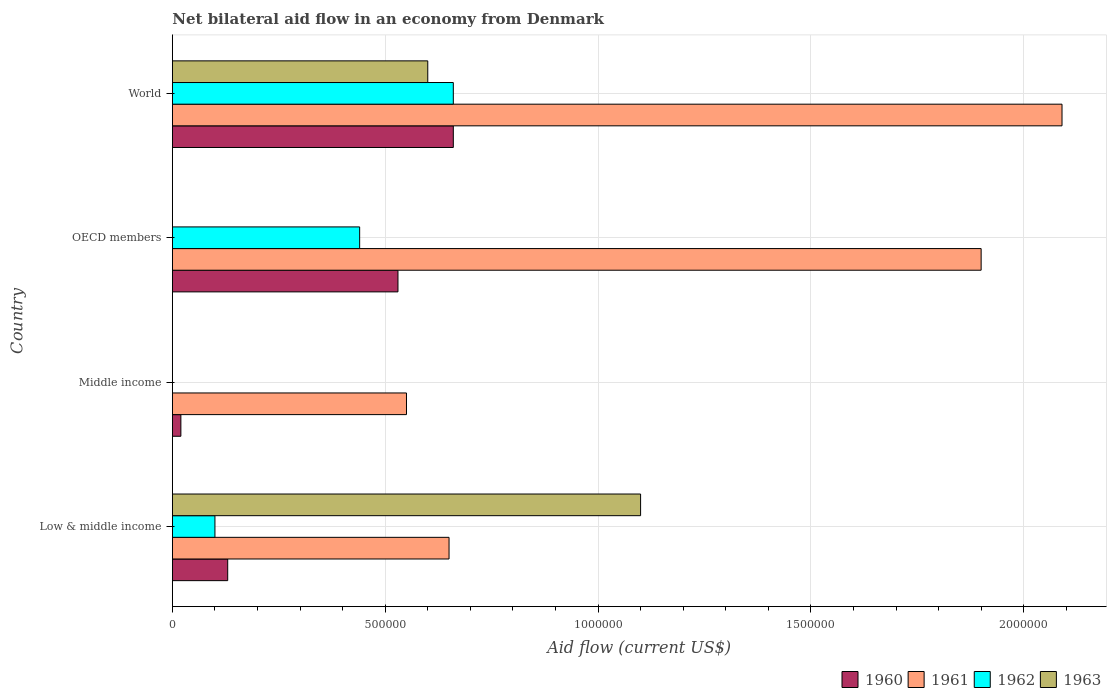How many different coloured bars are there?
Your response must be concise. 4. How many groups of bars are there?
Your answer should be very brief. 4. Are the number of bars per tick equal to the number of legend labels?
Your response must be concise. No. Are the number of bars on each tick of the Y-axis equal?
Your answer should be very brief. No. In how many cases, is the number of bars for a given country not equal to the number of legend labels?
Offer a terse response. 2. Across all countries, what is the maximum net bilateral aid flow in 1961?
Your answer should be compact. 2.09e+06. What is the total net bilateral aid flow in 1963 in the graph?
Ensure brevity in your answer.  1.70e+06. What is the difference between the net bilateral aid flow in 1960 in Middle income and that in OECD members?
Give a very brief answer. -5.10e+05. What is the difference between the net bilateral aid flow in 1963 in OECD members and the net bilateral aid flow in 1962 in World?
Your response must be concise. -6.60e+05. What is the difference between the net bilateral aid flow in 1960 and net bilateral aid flow in 1961 in OECD members?
Make the answer very short. -1.37e+06. In how many countries, is the net bilateral aid flow in 1963 greater than 1800000 US$?
Give a very brief answer. 0. What is the ratio of the net bilateral aid flow in 1961 in Low & middle income to that in World?
Give a very brief answer. 0.31. Is the net bilateral aid flow in 1961 in Middle income less than that in OECD members?
Give a very brief answer. Yes. Is the difference between the net bilateral aid flow in 1960 in Middle income and OECD members greater than the difference between the net bilateral aid flow in 1961 in Middle income and OECD members?
Provide a succinct answer. Yes. What is the difference between the highest and the second highest net bilateral aid flow in 1960?
Make the answer very short. 1.30e+05. What is the difference between the highest and the lowest net bilateral aid flow in 1963?
Your answer should be very brief. 1.10e+06. Are all the bars in the graph horizontal?
Your answer should be very brief. Yes. Are the values on the major ticks of X-axis written in scientific E-notation?
Make the answer very short. No. Does the graph contain grids?
Offer a terse response. Yes. How many legend labels are there?
Provide a succinct answer. 4. What is the title of the graph?
Provide a short and direct response. Net bilateral aid flow in an economy from Denmark. Does "2003" appear as one of the legend labels in the graph?
Offer a very short reply. No. What is the label or title of the X-axis?
Your answer should be very brief. Aid flow (current US$). What is the Aid flow (current US$) of 1961 in Low & middle income?
Your response must be concise. 6.50e+05. What is the Aid flow (current US$) in 1963 in Low & middle income?
Your response must be concise. 1.10e+06. What is the Aid flow (current US$) in 1960 in Middle income?
Ensure brevity in your answer.  2.00e+04. What is the Aid flow (current US$) in 1961 in Middle income?
Your response must be concise. 5.50e+05. What is the Aid flow (current US$) in 1960 in OECD members?
Offer a very short reply. 5.30e+05. What is the Aid flow (current US$) in 1961 in OECD members?
Make the answer very short. 1.90e+06. What is the Aid flow (current US$) in 1960 in World?
Your answer should be compact. 6.60e+05. What is the Aid flow (current US$) in 1961 in World?
Provide a short and direct response. 2.09e+06. What is the Aid flow (current US$) in 1962 in World?
Give a very brief answer. 6.60e+05. What is the Aid flow (current US$) of 1963 in World?
Your answer should be very brief. 6.00e+05. Across all countries, what is the maximum Aid flow (current US$) in 1961?
Give a very brief answer. 2.09e+06. Across all countries, what is the maximum Aid flow (current US$) of 1962?
Your answer should be compact. 6.60e+05. Across all countries, what is the maximum Aid flow (current US$) in 1963?
Your answer should be compact. 1.10e+06. Across all countries, what is the minimum Aid flow (current US$) in 1961?
Your answer should be compact. 5.50e+05. Across all countries, what is the minimum Aid flow (current US$) in 1962?
Ensure brevity in your answer.  0. What is the total Aid flow (current US$) of 1960 in the graph?
Offer a very short reply. 1.34e+06. What is the total Aid flow (current US$) in 1961 in the graph?
Offer a very short reply. 5.19e+06. What is the total Aid flow (current US$) of 1962 in the graph?
Keep it short and to the point. 1.20e+06. What is the total Aid flow (current US$) in 1963 in the graph?
Offer a very short reply. 1.70e+06. What is the difference between the Aid flow (current US$) of 1960 in Low & middle income and that in OECD members?
Keep it short and to the point. -4.00e+05. What is the difference between the Aid flow (current US$) in 1961 in Low & middle income and that in OECD members?
Keep it short and to the point. -1.25e+06. What is the difference between the Aid flow (current US$) of 1962 in Low & middle income and that in OECD members?
Offer a terse response. -3.40e+05. What is the difference between the Aid flow (current US$) in 1960 in Low & middle income and that in World?
Your answer should be very brief. -5.30e+05. What is the difference between the Aid flow (current US$) in 1961 in Low & middle income and that in World?
Offer a very short reply. -1.44e+06. What is the difference between the Aid flow (current US$) in 1962 in Low & middle income and that in World?
Your response must be concise. -5.60e+05. What is the difference between the Aid flow (current US$) in 1963 in Low & middle income and that in World?
Provide a succinct answer. 5.00e+05. What is the difference between the Aid flow (current US$) in 1960 in Middle income and that in OECD members?
Offer a very short reply. -5.10e+05. What is the difference between the Aid flow (current US$) of 1961 in Middle income and that in OECD members?
Offer a terse response. -1.35e+06. What is the difference between the Aid flow (current US$) of 1960 in Middle income and that in World?
Give a very brief answer. -6.40e+05. What is the difference between the Aid flow (current US$) in 1961 in Middle income and that in World?
Give a very brief answer. -1.54e+06. What is the difference between the Aid flow (current US$) in 1960 in OECD members and that in World?
Ensure brevity in your answer.  -1.30e+05. What is the difference between the Aid flow (current US$) in 1961 in OECD members and that in World?
Provide a short and direct response. -1.90e+05. What is the difference between the Aid flow (current US$) in 1960 in Low & middle income and the Aid flow (current US$) in 1961 in Middle income?
Offer a terse response. -4.20e+05. What is the difference between the Aid flow (current US$) of 1960 in Low & middle income and the Aid flow (current US$) of 1961 in OECD members?
Your answer should be compact. -1.77e+06. What is the difference between the Aid flow (current US$) in 1960 in Low & middle income and the Aid flow (current US$) in 1962 in OECD members?
Provide a succinct answer. -3.10e+05. What is the difference between the Aid flow (current US$) of 1961 in Low & middle income and the Aid flow (current US$) of 1962 in OECD members?
Keep it short and to the point. 2.10e+05. What is the difference between the Aid flow (current US$) in 1960 in Low & middle income and the Aid flow (current US$) in 1961 in World?
Give a very brief answer. -1.96e+06. What is the difference between the Aid flow (current US$) in 1960 in Low & middle income and the Aid flow (current US$) in 1962 in World?
Ensure brevity in your answer.  -5.30e+05. What is the difference between the Aid flow (current US$) in 1960 in Low & middle income and the Aid flow (current US$) in 1963 in World?
Keep it short and to the point. -4.70e+05. What is the difference between the Aid flow (current US$) of 1962 in Low & middle income and the Aid flow (current US$) of 1963 in World?
Give a very brief answer. -5.00e+05. What is the difference between the Aid flow (current US$) in 1960 in Middle income and the Aid flow (current US$) in 1961 in OECD members?
Give a very brief answer. -1.88e+06. What is the difference between the Aid flow (current US$) in 1960 in Middle income and the Aid flow (current US$) in 1962 in OECD members?
Give a very brief answer. -4.20e+05. What is the difference between the Aid flow (current US$) in 1960 in Middle income and the Aid flow (current US$) in 1961 in World?
Offer a very short reply. -2.07e+06. What is the difference between the Aid flow (current US$) in 1960 in Middle income and the Aid flow (current US$) in 1962 in World?
Your answer should be compact. -6.40e+05. What is the difference between the Aid flow (current US$) of 1960 in Middle income and the Aid flow (current US$) of 1963 in World?
Your response must be concise. -5.80e+05. What is the difference between the Aid flow (current US$) of 1961 in Middle income and the Aid flow (current US$) of 1962 in World?
Make the answer very short. -1.10e+05. What is the difference between the Aid flow (current US$) in 1961 in Middle income and the Aid flow (current US$) in 1963 in World?
Your answer should be very brief. -5.00e+04. What is the difference between the Aid flow (current US$) in 1960 in OECD members and the Aid flow (current US$) in 1961 in World?
Make the answer very short. -1.56e+06. What is the difference between the Aid flow (current US$) of 1960 in OECD members and the Aid flow (current US$) of 1962 in World?
Your response must be concise. -1.30e+05. What is the difference between the Aid flow (current US$) of 1960 in OECD members and the Aid flow (current US$) of 1963 in World?
Make the answer very short. -7.00e+04. What is the difference between the Aid flow (current US$) in 1961 in OECD members and the Aid flow (current US$) in 1962 in World?
Offer a terse response. 1.24e+06. What is the difference between the Aid flow (current US$) of 1961 in OECD members and the Aid flow (current US$) of 1963 in World?
Offer a very short reply. 1.30e+06. What is the difference between the Aid flow (current US$) in 1962 in OECD members and the Aid flow (current US$) in 1963 in World?
Your response must be concise. -1.60e+05. What is the average Aid flow (current US$) in 1960 per country?
Your answer should be compact. 3.35e+05. What is the average Aid flow (current US$) of 1961 per country?
Ensure brevity in your answer.  1.30e+06. What is the average Aid flow (current US$) in 1962 per country?
Give a very brief answer. 3.00e+05. What is the average Aid flow (current US$) of 1963 per country?
Provide a short and direct response. 4.25e+05. What is the difference between the Aid flow (current US$) in 1960 and Aid flow (current US$) in 1961 in Low & middle income?
Offer a terse response. -5.20e+05. What is the difference between the Aid flow (current US$) of 1960 and Aid flow (current US$) of 1963 in Low & middle income?
Provide a short and direct response. -9.70e+05. What is the difference between the Aid flow (current US$) of 1961 and Aid flow (current US$) of 1962 in Low & middle income?
Provide a short and direct response. 5.50e+05. What is the difference between the Aid flow (current US$) of 1961 and Aid flow (current US$) of 1963 in Low & middle income?
Your answer should be very brief. -4.50e+05. What is the difference between the Aid flow (current US$) of 1962 and Aid flow (current US$) of 1963 in Low & middle income?
Your response must be concise. -1.00e+06. What is the difference between the Aid flow (current US$) of 1960 and Aid flow (current US$) of 1961 in Middle income?
Offer a very short reply. -5.30e+05. What is the difference between the Aid flow (current US$) in 1960 and Aid flow (current US$) in 1961 in OECD members?
Offer a terse response. -1.37e+06. What is the difference between the Aid flow (current US$) in 1961 and Aid flow (current US$) in 1962 in OECD members?
Provide a succinct answer. 1.46e+06. What is the difference between the Aid flow (current US$) of 1960 and Aid flow (current US$) of 1961 in World?
Provide a short and direct response. -1.43e+06. What is the difference between the Aid flow (current US$) in 1961 and Aid flow (current US$) in 1962 in World?
Your answer should be very brief. 1.43e+06. What is the difference between the Aid flow (current US$) of 1961 and Aid flow (current US$) of 1963 in World?
Make the answer very short. 1.49e+06. What is the difference between the Aid flow (current US$) of 1962 and Aid flow (current US$) of 1963 in World?
Provide a short and direct response. 6.00e+04. What is the ratio of the Aid flow (current US$) in 1960 in Low & middle income to that in Middle income?
Ensure brevity in your answer.  6.5. What is the ratio of the Aid flow (current US$) in 1961 in Low & middle income to that in Middle income?
Give a very brief answer. 1.18. What is the ratio of the Aid flow (current US$) of 1960 in Low & middle income to that in OECD members?
Your answer should be very brief. 0.25. What is the ratio of the Aid flow (current US$) in 1961 in Low & middle income to that in OECD members?
Your answer should be very brief. 0.34. What is the ratio of the Aid flow (current US$) of 1962 in Low & middle income to that in OECD members?
Offer a terse response. 0.23. What is the ratio of the Aid flow (current US$) of 1960 in Low & middle income to that in World?
Your response must be concise. 0.2. What is the ratio of the Aid flow (current US$) in 1961 in Low & middle income to that in World?
Your answer should be very brief. 0.31. What is the ratio of the Aid flow (current US$) in 1962 in Low & middle income to that in World?
Your answer should be very brief. 0.15. What is the ratio of the Aid flow (current US$) of 1963 in Low & middle income to that in World?
Keep it short and to the point. 1.83. What is the ratio of the Aid flow (current US$) of 1960 in Middle income to that in OECD members?
Your answer should be compact. 0.04. What is the ratio of the Aid flow (current US$) of 1961 in Middle income to that in OECD members?
Provide a short and direct response. 0.29. What is the ratio of the Aid flow (current US$) in 1960 in Middle income to that in World?
Keep it short and to the point. 0.03. What is the ratio of the Aid flow (current US$) of 1961 in Middle income to that in World?
Provide a short and direct response. 0.26. What is the ratio of the Aid flow (current US$) of 1960 in OECD members to that in World?
Ensure brevity in your answer.  0.8. What is the difference between the highest and the second highest Aid flow (current US$) in 1961?
Offer a terse response. 1.90e+05. What is the difference between the highest and the second highest Aid flow (current US$) in 1962?
Offer a very short reply. 2.20e+05. What is the difference between the highest and the lowest Aid flow (current US$) in 1960?
Your answer should be very brief. 6.40e+05. What is the difference between the highest and the lowest Aid flow (current US$) in 1961?
Provide a succinct answer. 1.54e+06. What is the difference between the highest and the lowest Aid flow (current US$) in 1963?
Provide a succinct answer. 1.10e+06. 